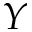Convert formula to latex. <formula><loc_0><loc_0><loc_500><loc_500>Y</formula> 